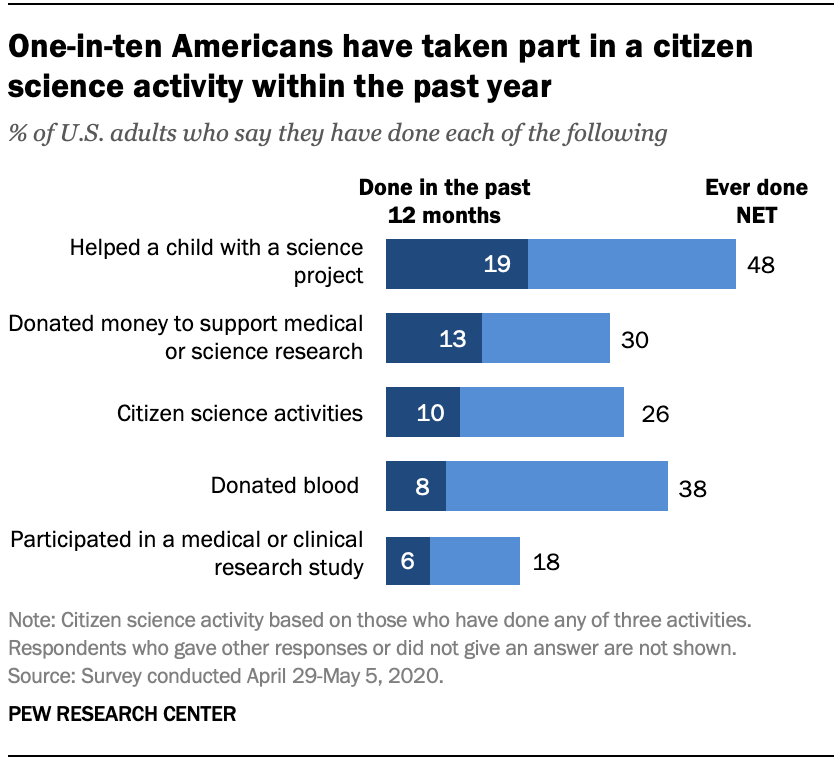Draw attention to some important aspects in this diagram. The ratio of the two smallest navy blue bars in the A:B ratio is 0.16875. The bars are smaller than B and A is larger than B in this ratio. In the past 12 months, approximately 0.08% of adults in the United States have donated blood. 